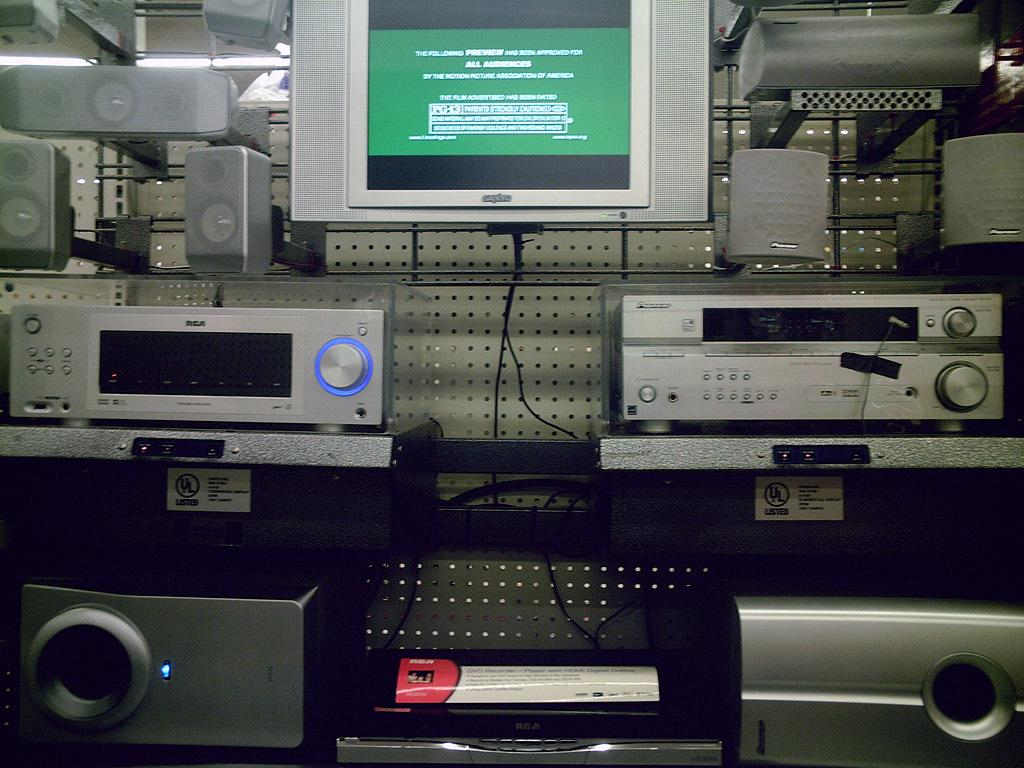Provide a one-sentence caption for the provided image. An approval rating for everyone is shown on the television screen. 